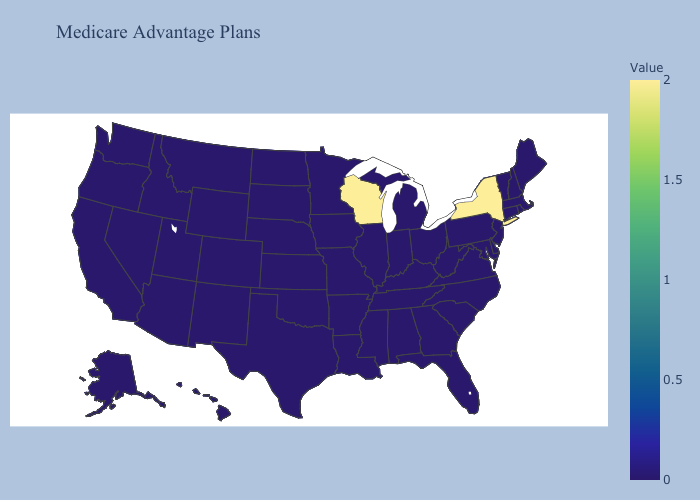Does New York have the lowest value in the USA?
Give a very brief answer. No. Does the map have missing data?
Write a very short answer. No. Which states have the highest value in the USA?
Give a very brief answer. New York, Wisconsin. Among the states that border Massachusetts , which have the highest value?
Give a very brief answer. New York. Does Maine have the highest value in the Northeast?
Be succinct. No. Does Vermont have the highest value in the USA?
Keep it brief. No. Does Wisconsin have the highest value in the USA?
Keep it brief. Yes. 